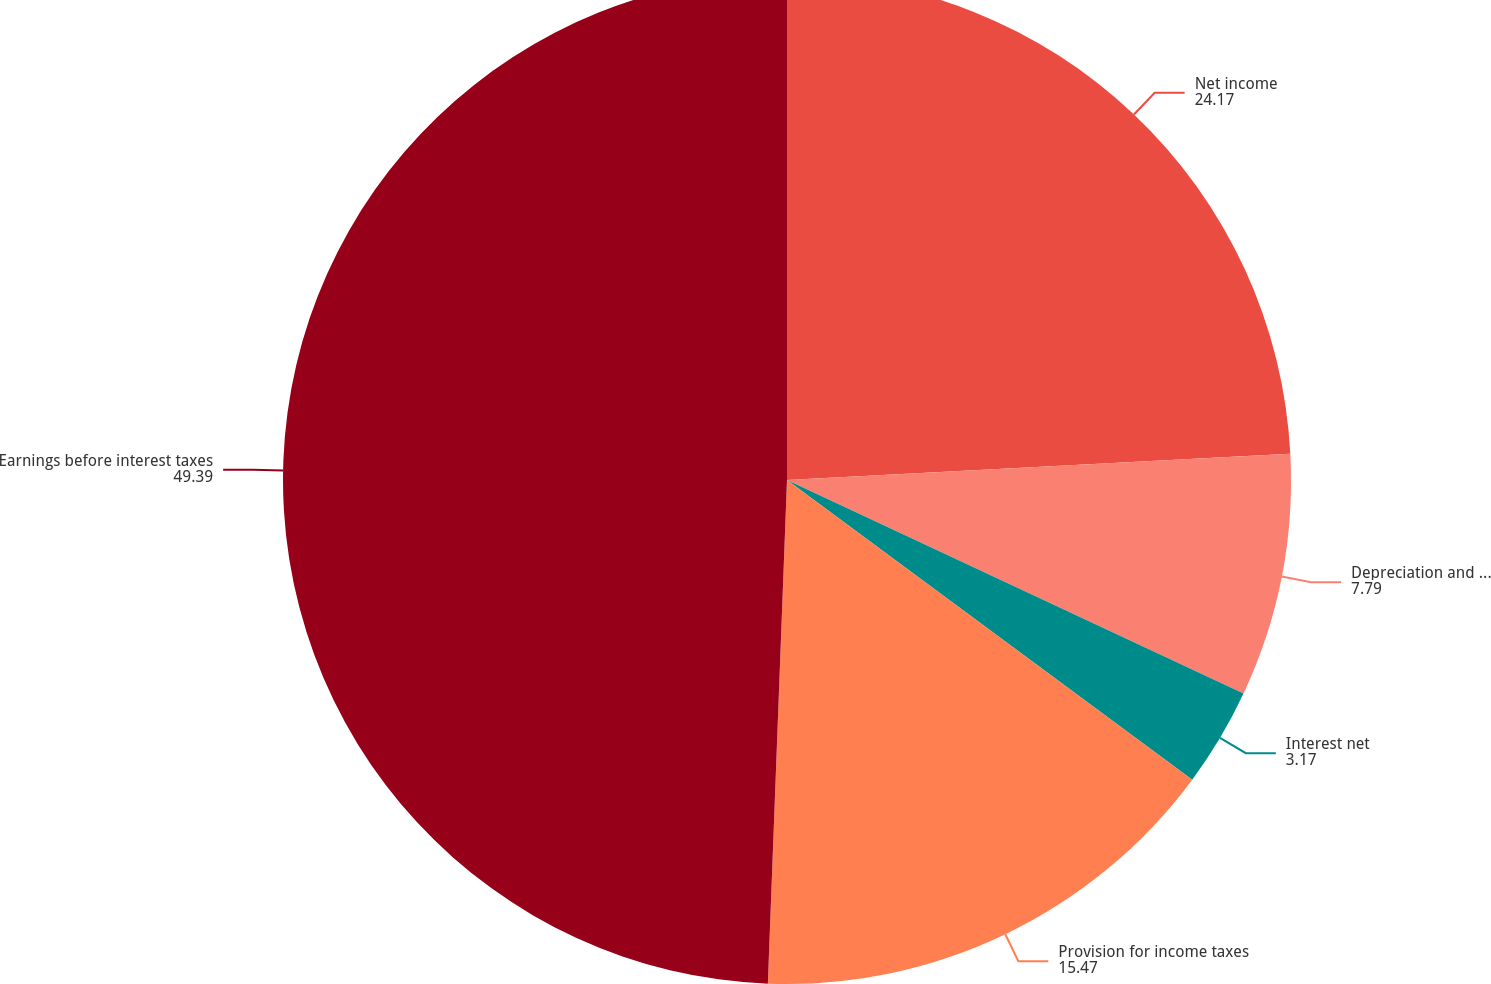Convert chart. <chart><loc_0><loc_0><loc_500><loc_500><pie_chart><fcel>Net income<fcel>Depreciation and amortization<fcel>Interest net<fcel>Provision for income taxes<fcel>Earnings before interest taxes<nl><fcel>24.17%<fcel>7.79%<fcel>3.17%<fcel>15.47%<fcel>49.39%<nl></chart> 